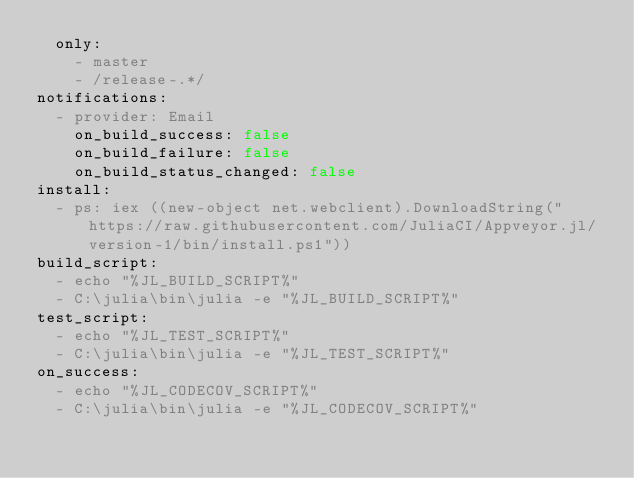<code> <loc_0><loc_0><loc_500><loc_500><_YAML_>  only:
    - master
    - /release-.*/
notifications:
  - provider: Email
    on_build_success: false
    on_build_failure: false
    on_build_status_changed: false
install:
  - ps: iex ((new-object net.webclient).DownloadString("https://raw.githubusercontent.com/JuliaCI/Appveyor.jl/version-1/bin/install.ps1"))
build_script:
  - echo "%JL_BUILD_SCRIPT%"
  - C:\julia\bin\julia -e "%JL_BUILD_SCRIPT%"
test_script:
  - echo "%JL_TEST_SCRIPT%"
  - C:\julia\bin\julia -e "%JL_TEST_SCRIPT%"
on_success:
  - echo "%JL_CODECOV_SCRIPT%"
  - C:\julia\bin\julia -e "%JL_CODECOV_SCRIPT%"
</code> 